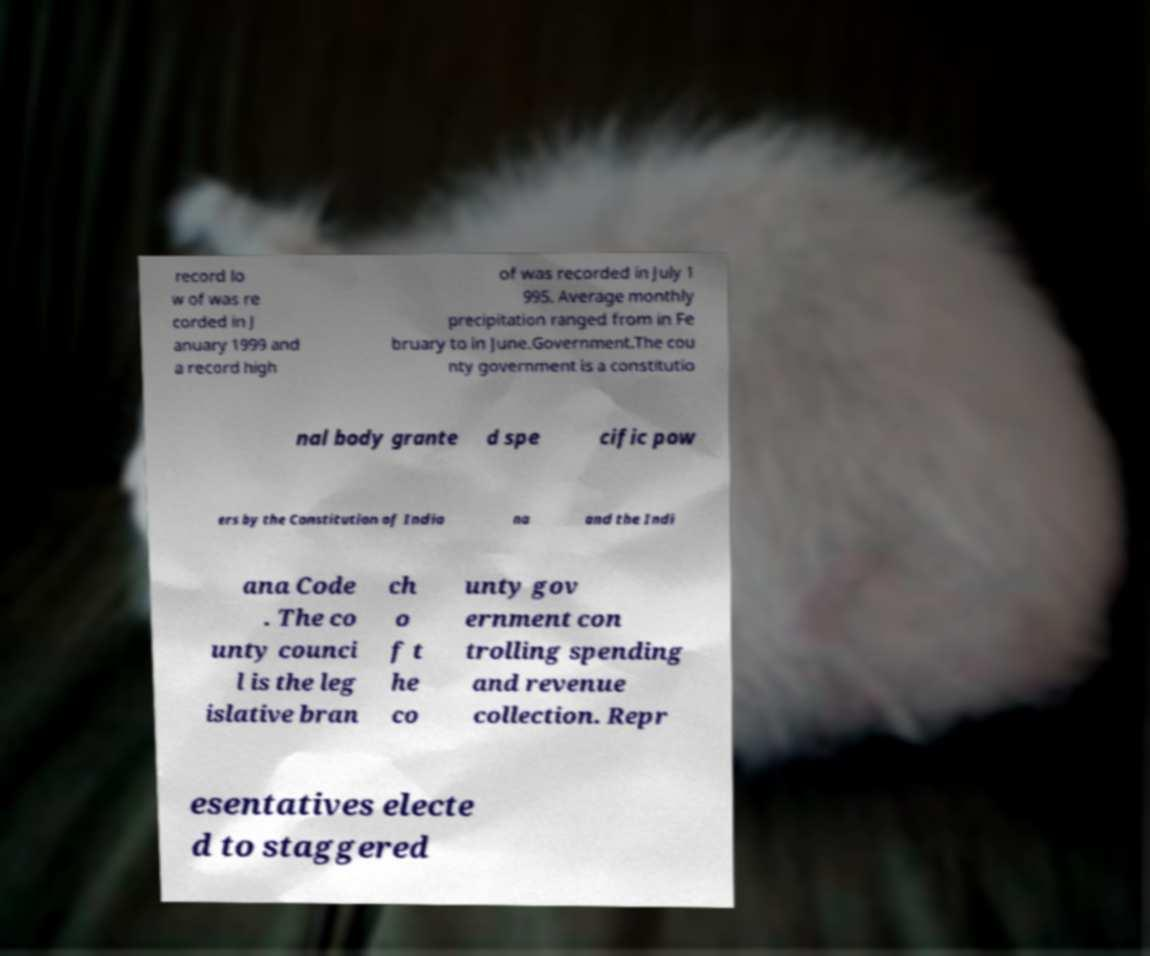For documentation purposes, I need the text within this image transcribed. Could you provide that? record lo w of was re corded in J anuary 1999 and a record high of was recorded in July 1 995. Average monthly precipitation ranged from in Fe bruary to in June.Government.The cou nty government is a constitutio nal body grante d spe cific pow ers by the Constitution of India na and the Indi ana Code . The co unty counci l is the leg islative bran ch o f t he co unty gov ernment con trolling spending and revenue collection. Repr esentatives electe d to staggered 